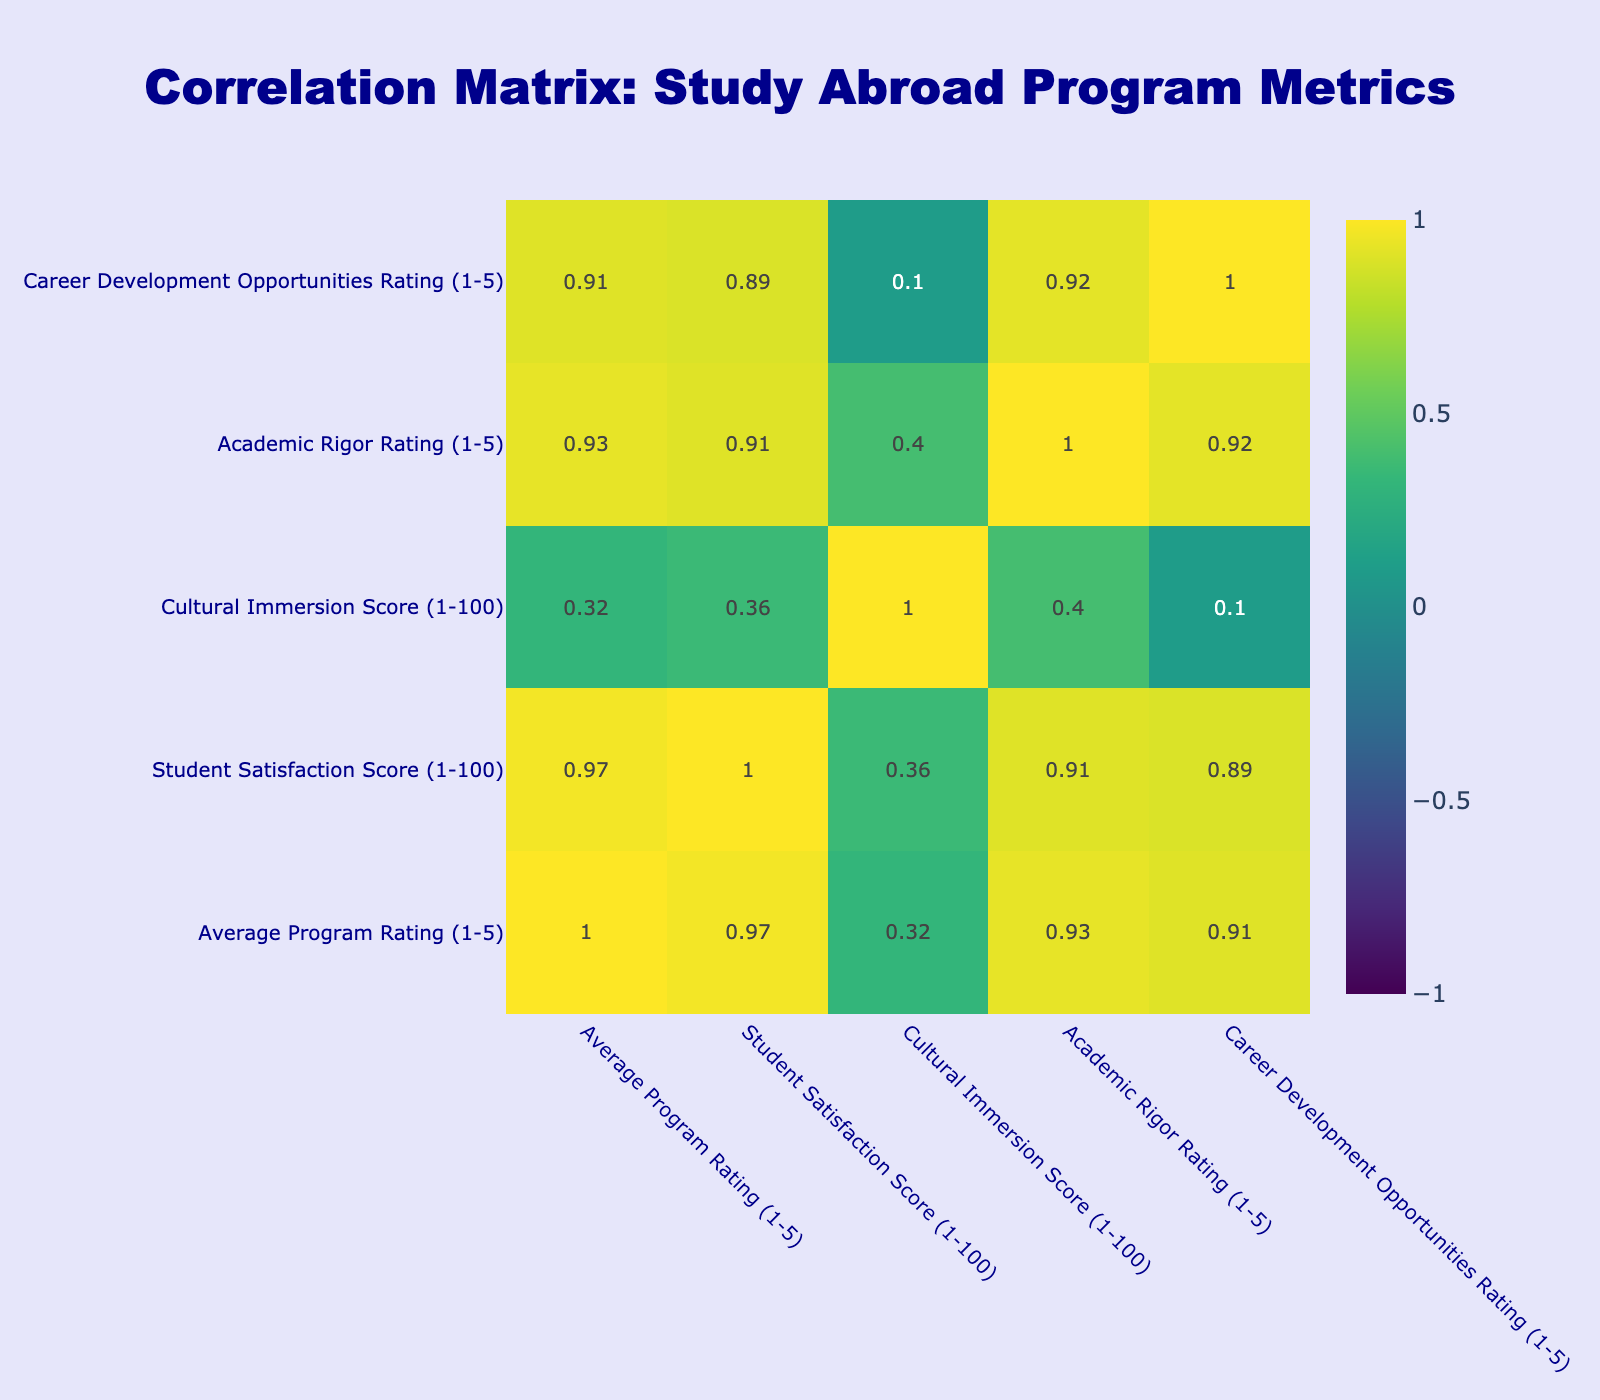What is the Average Program Rating of the University of Oxford Summer School? The table shows that the University of Oxford Summer School has an Average Program Rating of 4.9.
Answer: 4.9 What is the Student Satisfaction Score of the University of Cape Town Study Abroad Program? According to the table, the University of Cape Town Study Abroad Program has a Student Satisfaction Score of 80.
Answer: 80 Which program has the highest Cultural Immersion Score? The table indicates that the University of Cape Town Study Abroad Program has the highest Cultural Immersion Score at 95.
Answer: 95 Is the Average Program Rating of the University of Toronto International Learning higher than that of the University of São Paulo Cultural Exchange? The University of Toronto International Learning has an Average Program Rating of 4.8, whereas the University of São Paulo Cultural Exchange has a rating of 4.2. Therefore, it is true that the University of Toronto has a higher rating.
Answer: Yes What is the difference between the highest and lowest Student Satisfaction Scores in the table? The highest Student Satisfaction Score is 98 from the University of Oxford Summer School and the lowest is 70 from the University of Beijing International Exchange. Calculating the difference gives us 98 - 70 = 28.
Answer: 28 Which program has both a Student Satisfaction Score greater than 90 and a Career Development Opportunities Rating of 5? The University of Toronto International Learning has a Student Satisfaction Score of 95 and a Career Development Opportunities Rating of 5. The University of Melbourne Exchange Program also meets these criteria with a score of 92 and a rating of 5.
Answer: University of Toronto International Learning and University of Melbourne Exchange Program What is the average Academic Rigor Rating of the study abroad programs listed? The Academic Rigor Ratings are 4, 5, 4, 4, 3, 5, 4, 5, 4, and 3. Adding these gives 4 + 5 + 4 + 4 + 3 + 5 + 4 + 5 + 4 + 3 = 45. There are 10 ratings, so the average is 45/10 = 4.5.
Answer: 4.5 Is the Cultural Immersion Score of the University of Melbourne Exchange Program greater than the average of all Cultural Immersion Scores? The Cultural Immersion Scores are 90, 85, 95, 80, 88, 90, 87, 92, 82, and 78. The average is (90 + 85 + 95 + 80 + 88 + 90 + 87 + 92 + 82 + 78) / 10 = 86.7. The score for the University of Melbourne is 85, which is less than the average. Therefore, it is false.
Answer: No Which program has the lowest Academic Rigor Rating, and what is its score? By examining the Academic Rigor Ratings, the program with the lowest rating is the University of São Paulo Cultural Exchange with a score of 3.
Answer: University of São Paulo Cultural Exchange, 3 